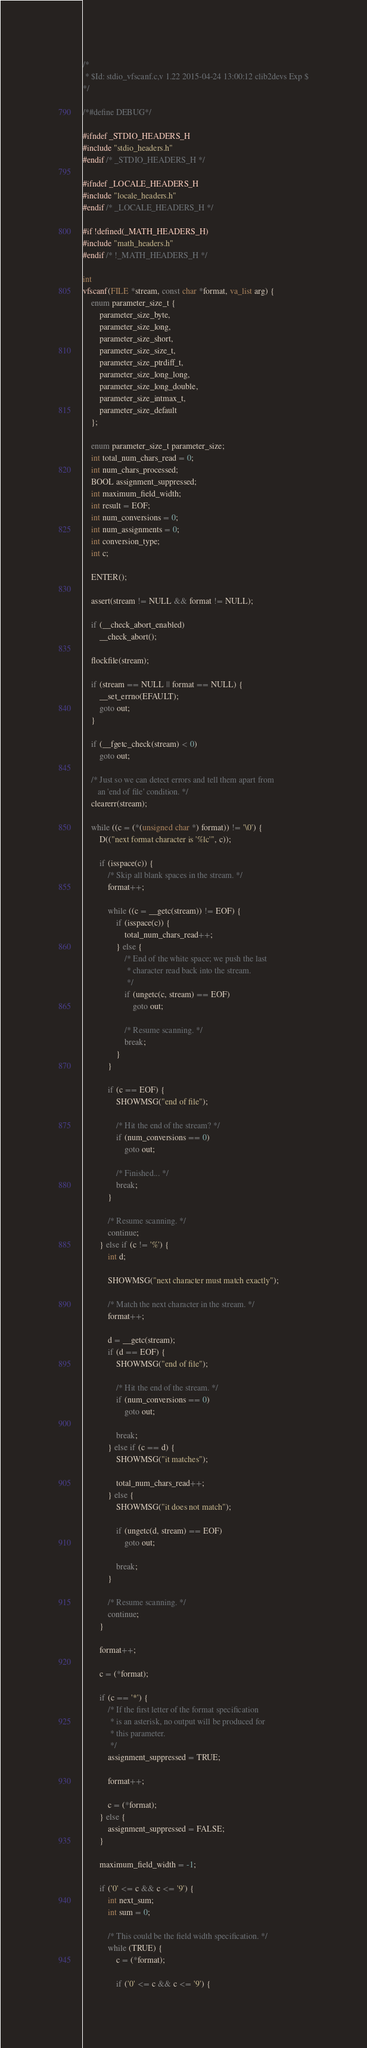Convert code to text. <code><loc_0><loc_0><loc_500><loc_500><_C_>/*
 * $Id: stdio_vfscanf.c,v 1.22 2015-04-24 13:00:12 clib2devs Exp $
*/

/*#define DEBUG*/

#ifndef _STDIO_HEADERS_H
#include "stdio_headers.h"
#endif /* _STDIO_HEADERS_H */

#ifndef _LOCALE_HEADERS_H
#include "locale_headers.h"
#endif /* _LOCALE_HEADERS_H */

#if !defined(_MATH_HEADERS_H)
#include "math_headers.h"
#endif /* !_MATH_HEADERS_H */

int
vfscanf(FILE *stream, const char *format, va_list arg) {
    enum parameter_size_t {
        parameter_size_byte,
        parameter_size_long,
        parameter_size_short,
        parameter_size_size_t,
        parameter_size_ptrdiff_t,
        parameter_size_long_long,
        parameter_size_long_double,
        parameter_size_intmax_t,
        parameter_size_default
    };

    enum parameter_size_t parameter_size;
    int total_num_chars_read = 0;
    int num_chars_processed;
    BOOL assignment_suppressed;
    int maximum_field_width;
    int result = EOF;
    int num_conversions = 0;
    int num_assignments = 0;
    int conversion_type;
    int c;

    ENTER();

    assert(stream != NULL && format != NULL);

    if (__check_abort_enabled)
        __check_abort();

    flockfile(stream);

    if (stream == NULL || format == NULL) {
        __set_errno(EFAULT);
        goto out;
    }

    if (__fgetc_check(stream) < 0)
        goto out;

    /* Just so we can detect errors and tell them apart from
       an 'end of file' condition. */
    clearerr(stream);

    while ((c = (*(unsigned char *) format)) != '\0') {
        D(("next format character is '%lc'", c));

        if (isspace(c)) {
            /* Skip all blank spaces in the stream. */
            format++;

            while ((c = __getc(stream)) != EOF) {
                if (isspace(c)) {
                    total_num_chars_read++;
                } else {
                    /* End of the white space; we push the last
                     * character read back into the stream.
                     */
                    if (ungetc(c, stream) == EOF)
                        goto out;

                    /* Resume scanning. */
                    break;
                }
            }

            if (c == EOF) {
                SHOWMSG("end of file");

                /* Hit the end of the stream? */
                if (num_conversions == 0)
                    goto out;

                /* Finished... */
                break;
            }

            /* Resume scanning. */
            continue;
        } else if (c != '%') {
            int d;

            SHOWMSG("next character must match exactly");

            /* Match the next character in the stream. */
            format++;

            d = __getc(stream);
            if (d == EOF) {
                SHOWMSG("end of file");

                /* Hit the end of the stream. */
                if (num_conversions == 0)
                    goto out;

                break;
            } else if (c == d) {
                SHOWMSG("it matches");

                total_num_chars_read++;
            } else {
                SHOWMSG("it does not match");

                if (ungetc(d, stream) == EOF)
                    goto out;

                break;
            }

            /* Resume scanning. */
            continue;
        }

        format++;

        c = (*format);

        if (c == '*') {
            /* If the first letter of the format specification
             * is an asterisk, no output will be produced for
             * this parameter.
             */
            assignment_suppressed = TRUE;

            format++;

            c = (*format);
        } else {
            assignment_suppressed = FALSE;
        }

        maximum_field_width = -1;

        if ('0' <= c && c <= '9') {
            int next_sum;
            int sum = 0;

            /* This could be the field width specification. */
            while (TRUE) {
                c = (*format);

                if ('0' <= c && c <= '9') {</code> 